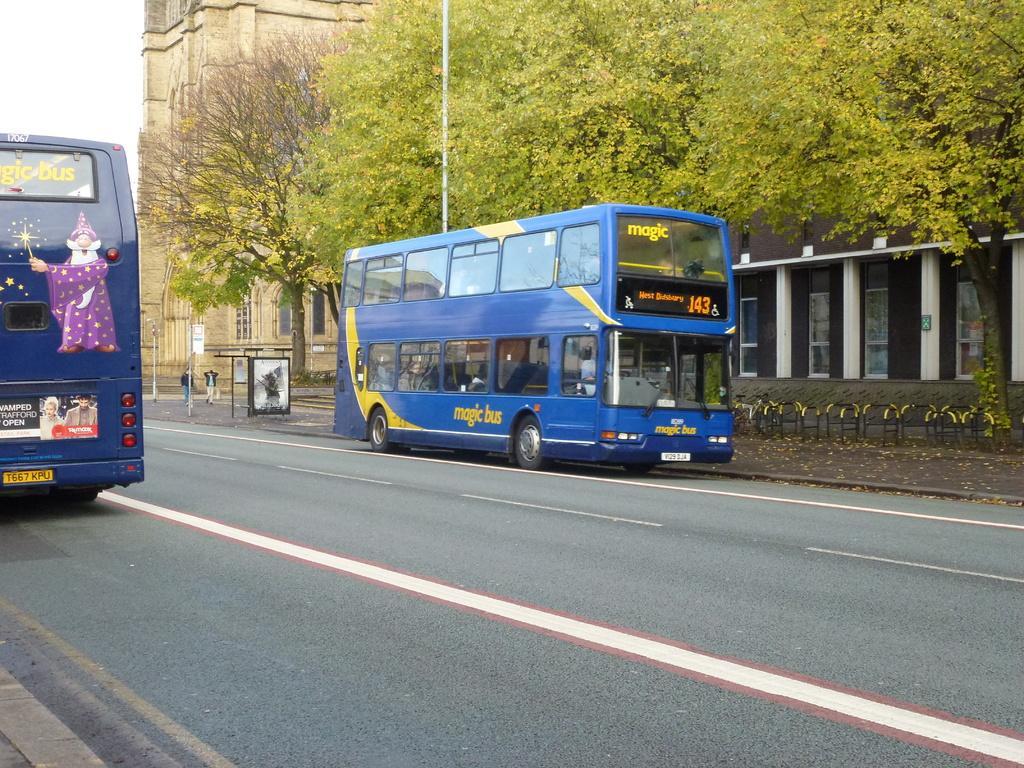Please provide a concise description of this image. This image is taken outdoors. At the bottom of the image there is a road. On the left side of the image a bus is parked on the road. On the right side of the image there are a few trees and a wall with doors and pillars. There are a few plants and a railing. A bus is parked on the road and there is a building with walls and windows and two men are walking on the road. 